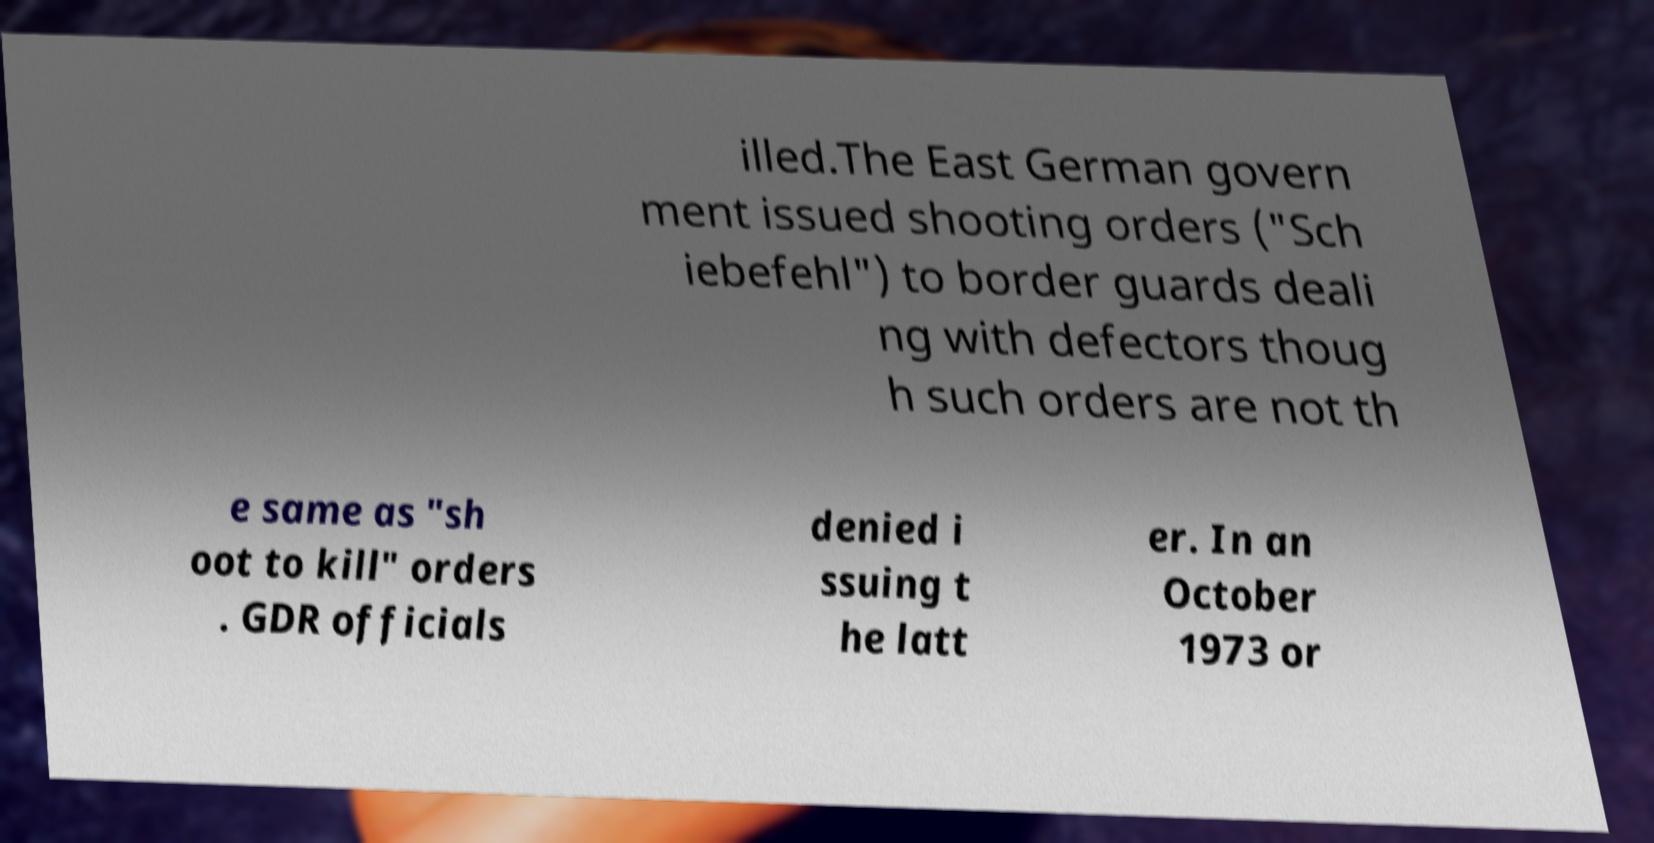I need the written content from this picture converted into text. Can you do that? illed.The East German govern ment issued shooting orders ("Sch iebefehl") to border guards deali ng with defectors thoug h such orders are not th e same as "sh oot to kill" orders . GDR officials denied i ssuing t he latt er. In an October 1973 or 